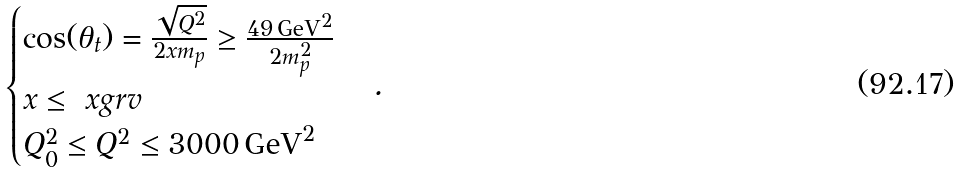Convert formula to latex. <formula><loc_0><loc_0><loc_500><loc_500>\begin{cases} \cos ( \theta _ { t } ) = \frac { \sqrt { Q ^ { 2 } } } { 2 x m _ { p } } \geq \frac { 4 9 \, \text {GeV} ^ { 2 } } { 2 m _ { p } ^ { 2 } } \\ x \leq \ x g r v \\ Q _ { 0 } ^ { 2 } \leq Q ^ { 2 } \leq 3 0 0 0 \, \text {GeV} ^ { 2 } \end{cases} .</formula> 